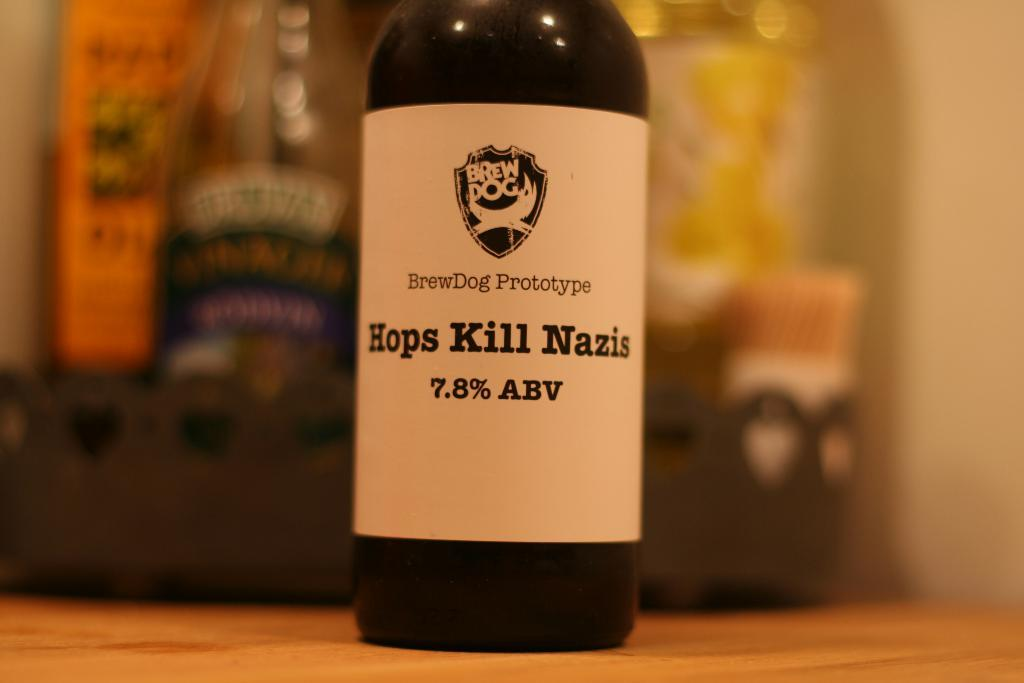<image>
Describe the image concisely. A bottle of alcohol with the words Hops Kill Nazis on the label, 